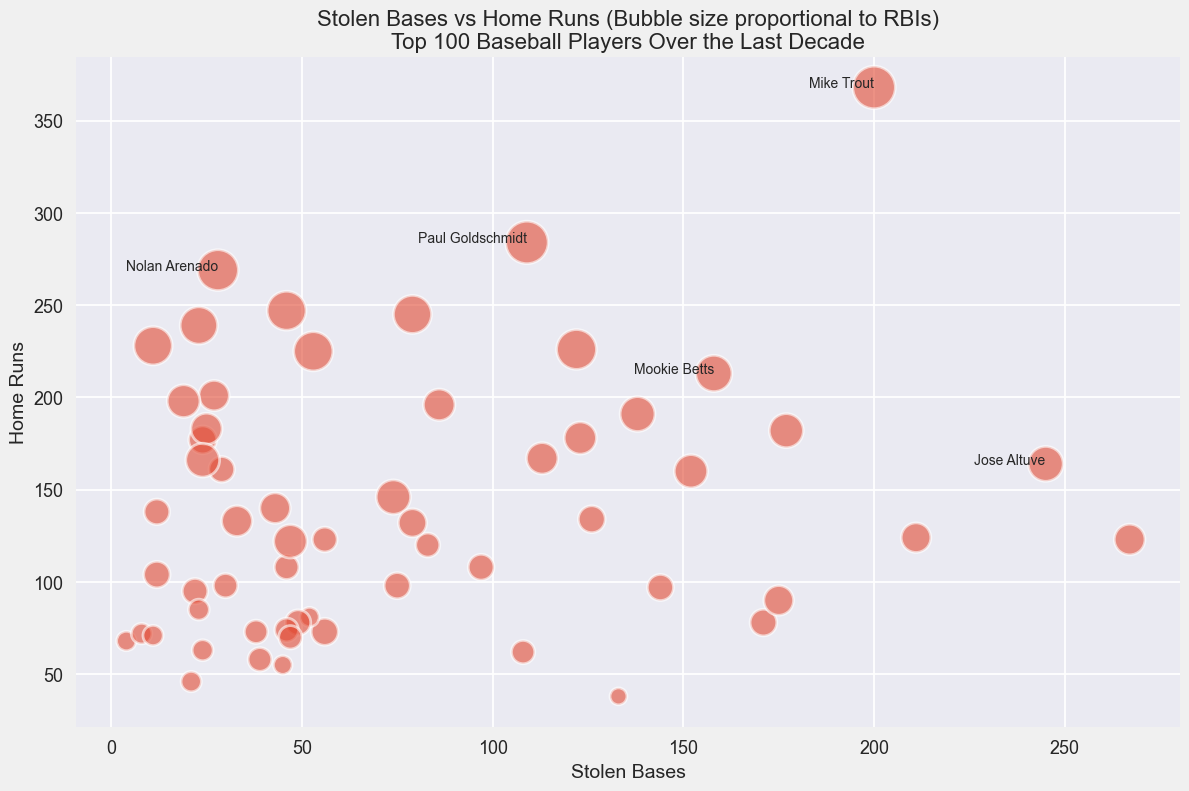Which player has the highest number of Stolen Bases? Locate the player with the bubble farthest to the right on the x-axis, which represents Stolen Bases.
Answer: Starling Marte Which player has the most RBIs among those with over 200 Stolen Bases? Find the bubbles for players with over 200 Stolen Bases, which are on the far right. Look for the largest bubble among them.
Answer: Mike Trout Compare Mike Trout and Mookie Betts in terms of Home Runs. Who has more? Look at the y-axis position of each player's bubble. Mike Trout is higher up on the y-axis, indicating more Home Runs.
Answer: Mike Trout Which two players have both Stolen Bases greater than 200 and at least 160 Home Runs? Look for bubbles that are right of the 200 mark on the x-axis and above the 160 mark on the y-axis.
Answer: Mike Trout, Starling Marte What is the average number of Stolen Bases for Mookie Betts and Jose Altuve? Mookie Betts has 158 Stolen Bases, and Jose Altuve has 245. Calculate the average: (158 + 245) / 2.
Answer: 201.5 Who has a higher ratio of Home Runs to Stolen Bases: Bryce Harper or Christian Yelich? Calculate the ratio for Bryce Harper: 226/122 ≈ 1.85. Calculate the ratio for Christian Yelich: 160/152 ≈ 1.05. Compare the two values.
Answer: Bryce Harper Between Bryce Harper and Javier Baez, who has more RBIs? Compare the size of their bubbles. Bryce Harper has a larger bubble, indicating more RBIs.
Answer: Bryce Harper Which player among the annotated ones (Mike Trout, Mookie Betts, Jose Altuve, Paul Goldschmidt, Nolan Arenado) has the fewest Home Runs? Look for the annotated bubble that is the lowest on the y-axis.
Answer: Jose Altuve What is the combined number of RBIs for Freddie Freeman and Anthony Rizzo? Add the RBIs for each player: Freddie Freeman (797) and Anthony Rizzo (786), so 797 + 786.
Answer: 1583 Which player has the largest bubble (most RBIs) among those with less than 100 Stolen Bases? Look for the largest bubble among those left of the 100 mark on the x-axis.
Answer: Nolan Arenado 